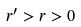<formula> <loc_0><loc_0><loc_500><loc_500>r ^ { \prime } > r > 0</formula> 